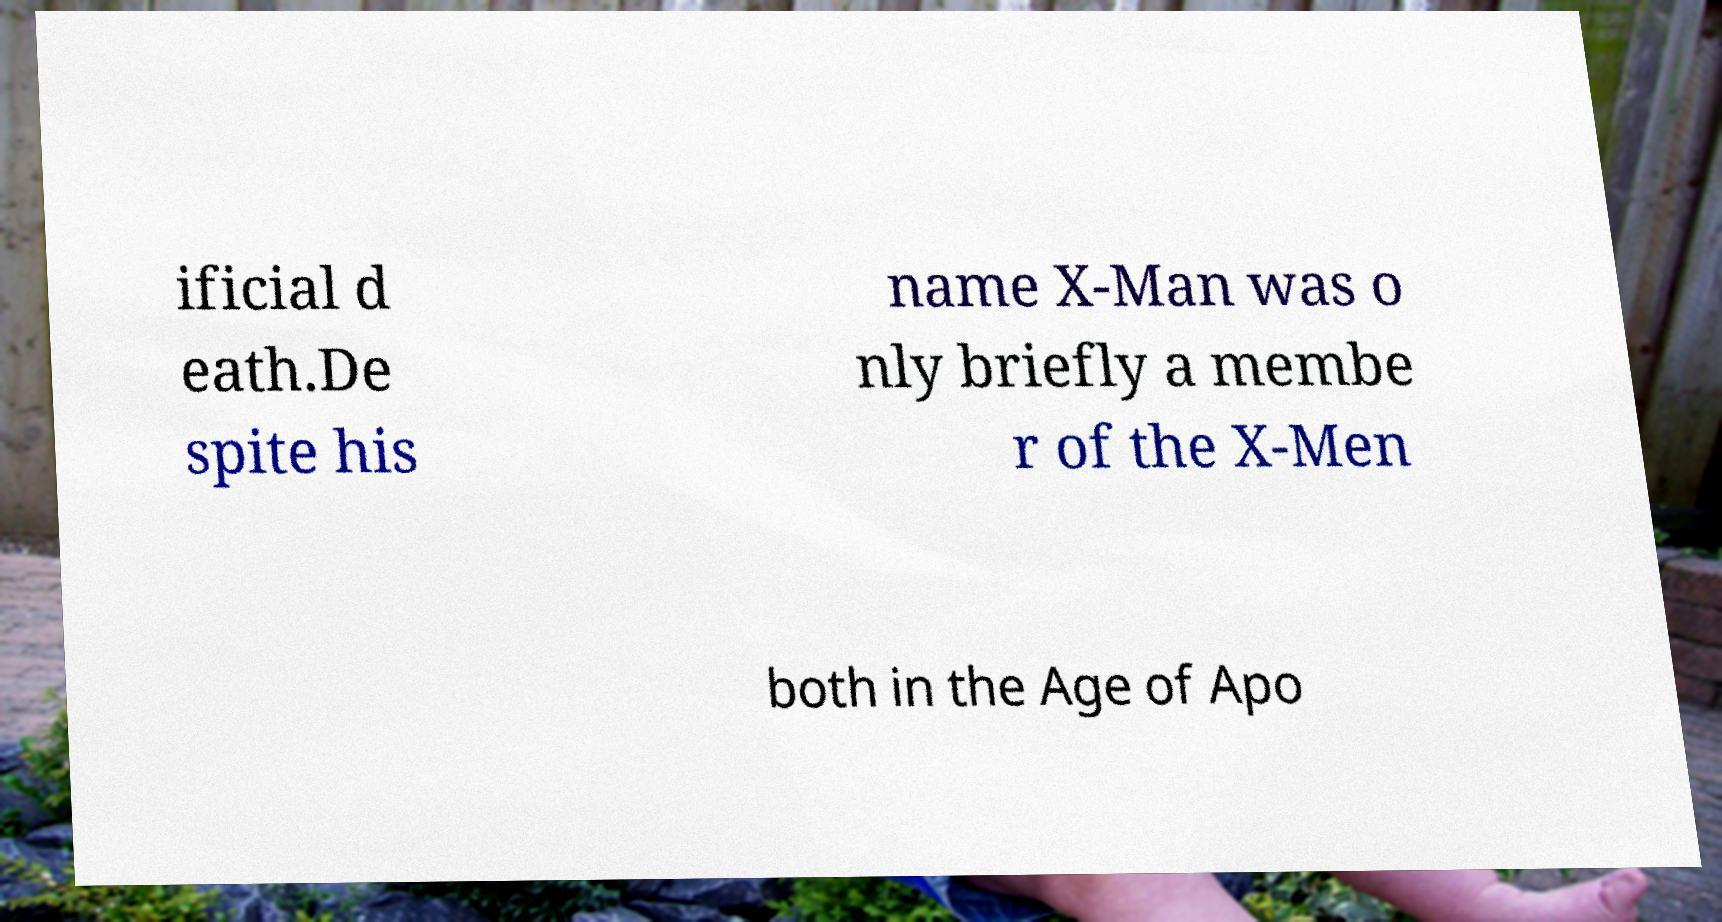For documentation purposes, I need the text within this image transcribed. Could you provide that? ificial d eath.De spite his name X-Man was o nly briefly a membe r of the X-Men both in the Age of Apo 